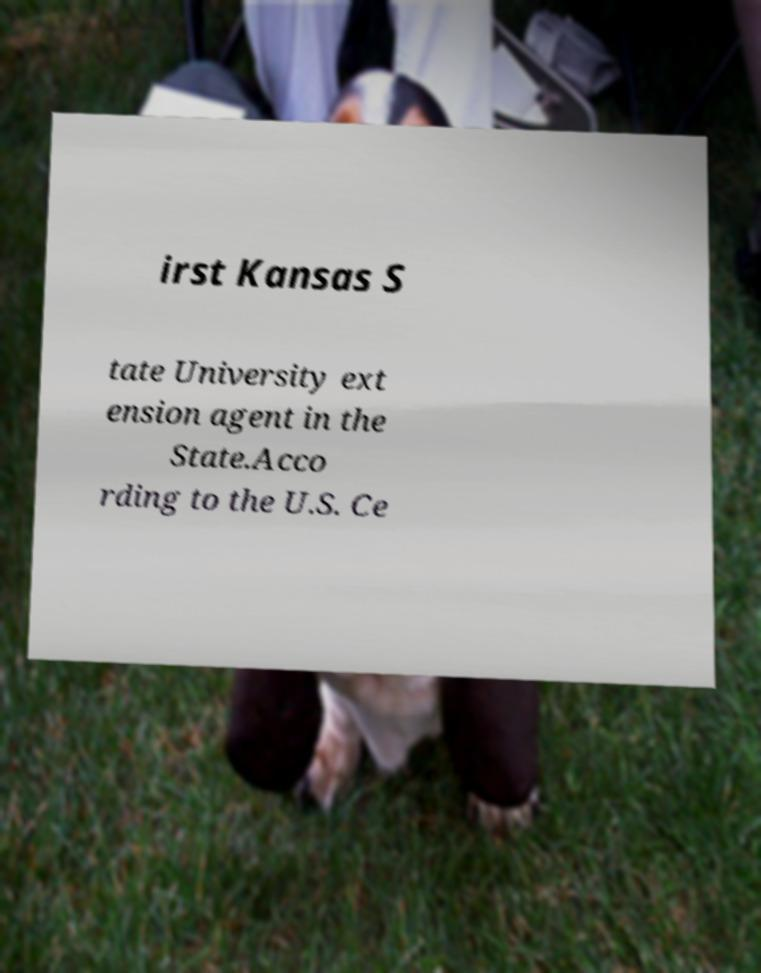Please identify and transcribe the text found in this image. irst Kansas S tate University ext ension agent in the State.Acco rding to the U.S. Ce 